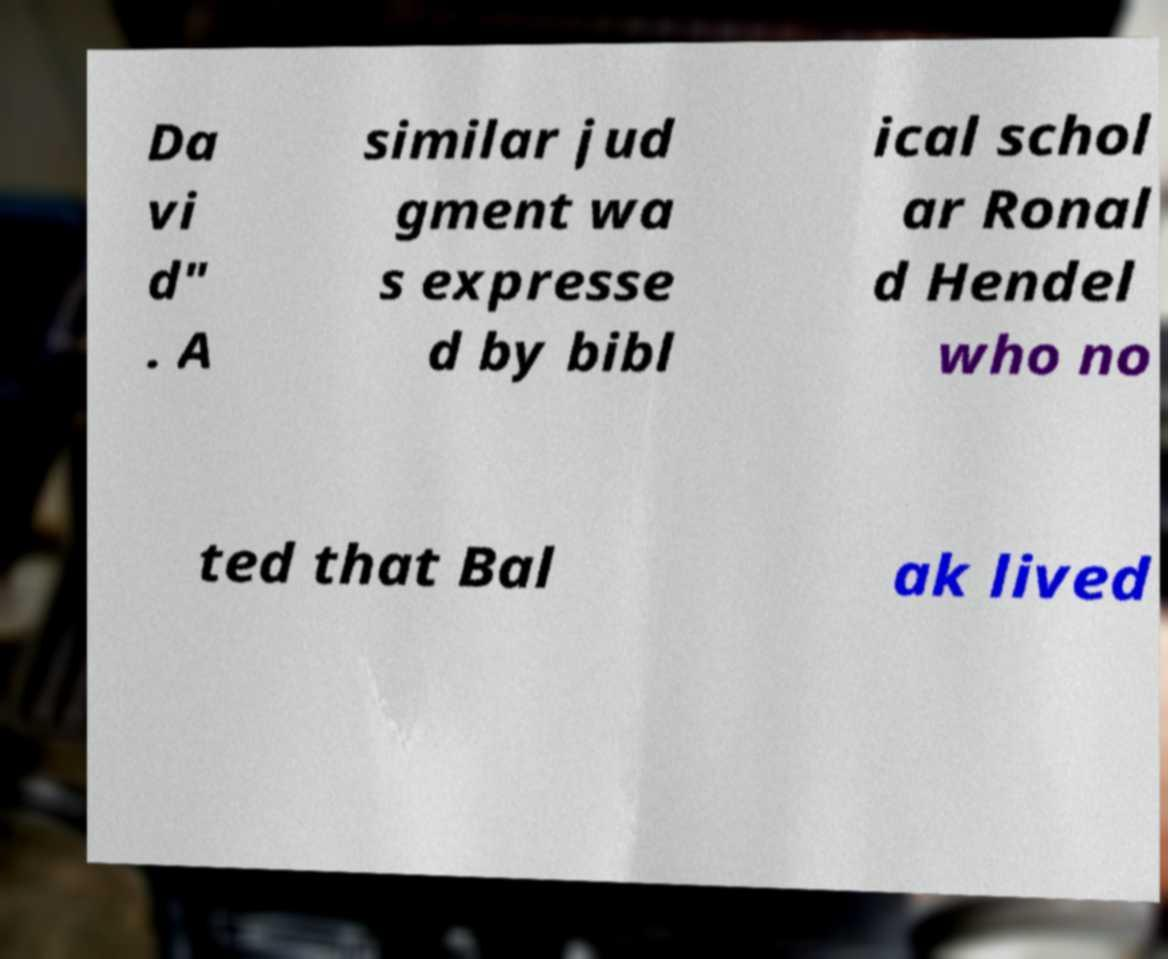Please identify and transcribe the text found in this image. Da vi d" . A similar jud gment wa s expresse d by bibl ical schol ar Ronal d Hendel who no ted that Bal ak lived 